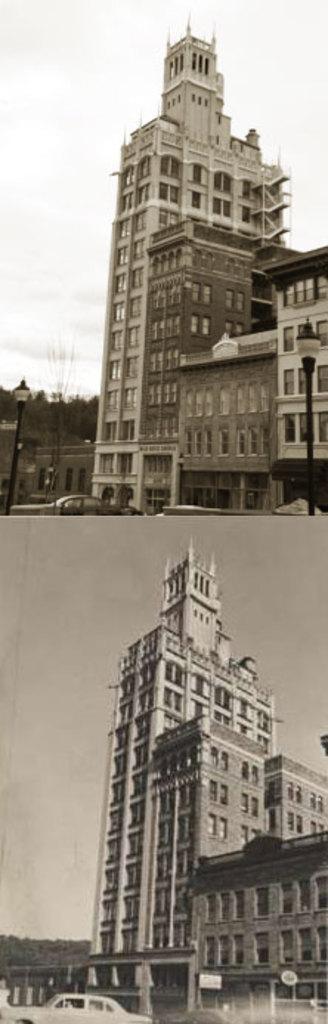How would you summarize this image in a sentence or two? This is a collage of two images. On the first image there is a building with windows. Also there is a light pole, car and sky in the background. On the second image there is a building with windows. Also there is a car and sky in the background. Both buildings are same. 